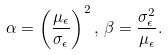<formula> <loc_0><loc_0><loc_500><loc_500>\alpha = \left ( \frac { \mu _ { \epsilon } } { \sigma _ { \epsilon } } \right ) ^ { 2 } , \, \beta = \frac { \sigma ^ { 2 } _ { \epsilon } } { \mu _ { \epsilon } } .</formula> 